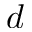Convert formula to latex. <formula><loc_0><loc_0><loc_500><loc_500>d</formula> 